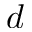Convert formula to latex. <formula><loc_0><loc_0><loc_500><loc_500>d</formula> 